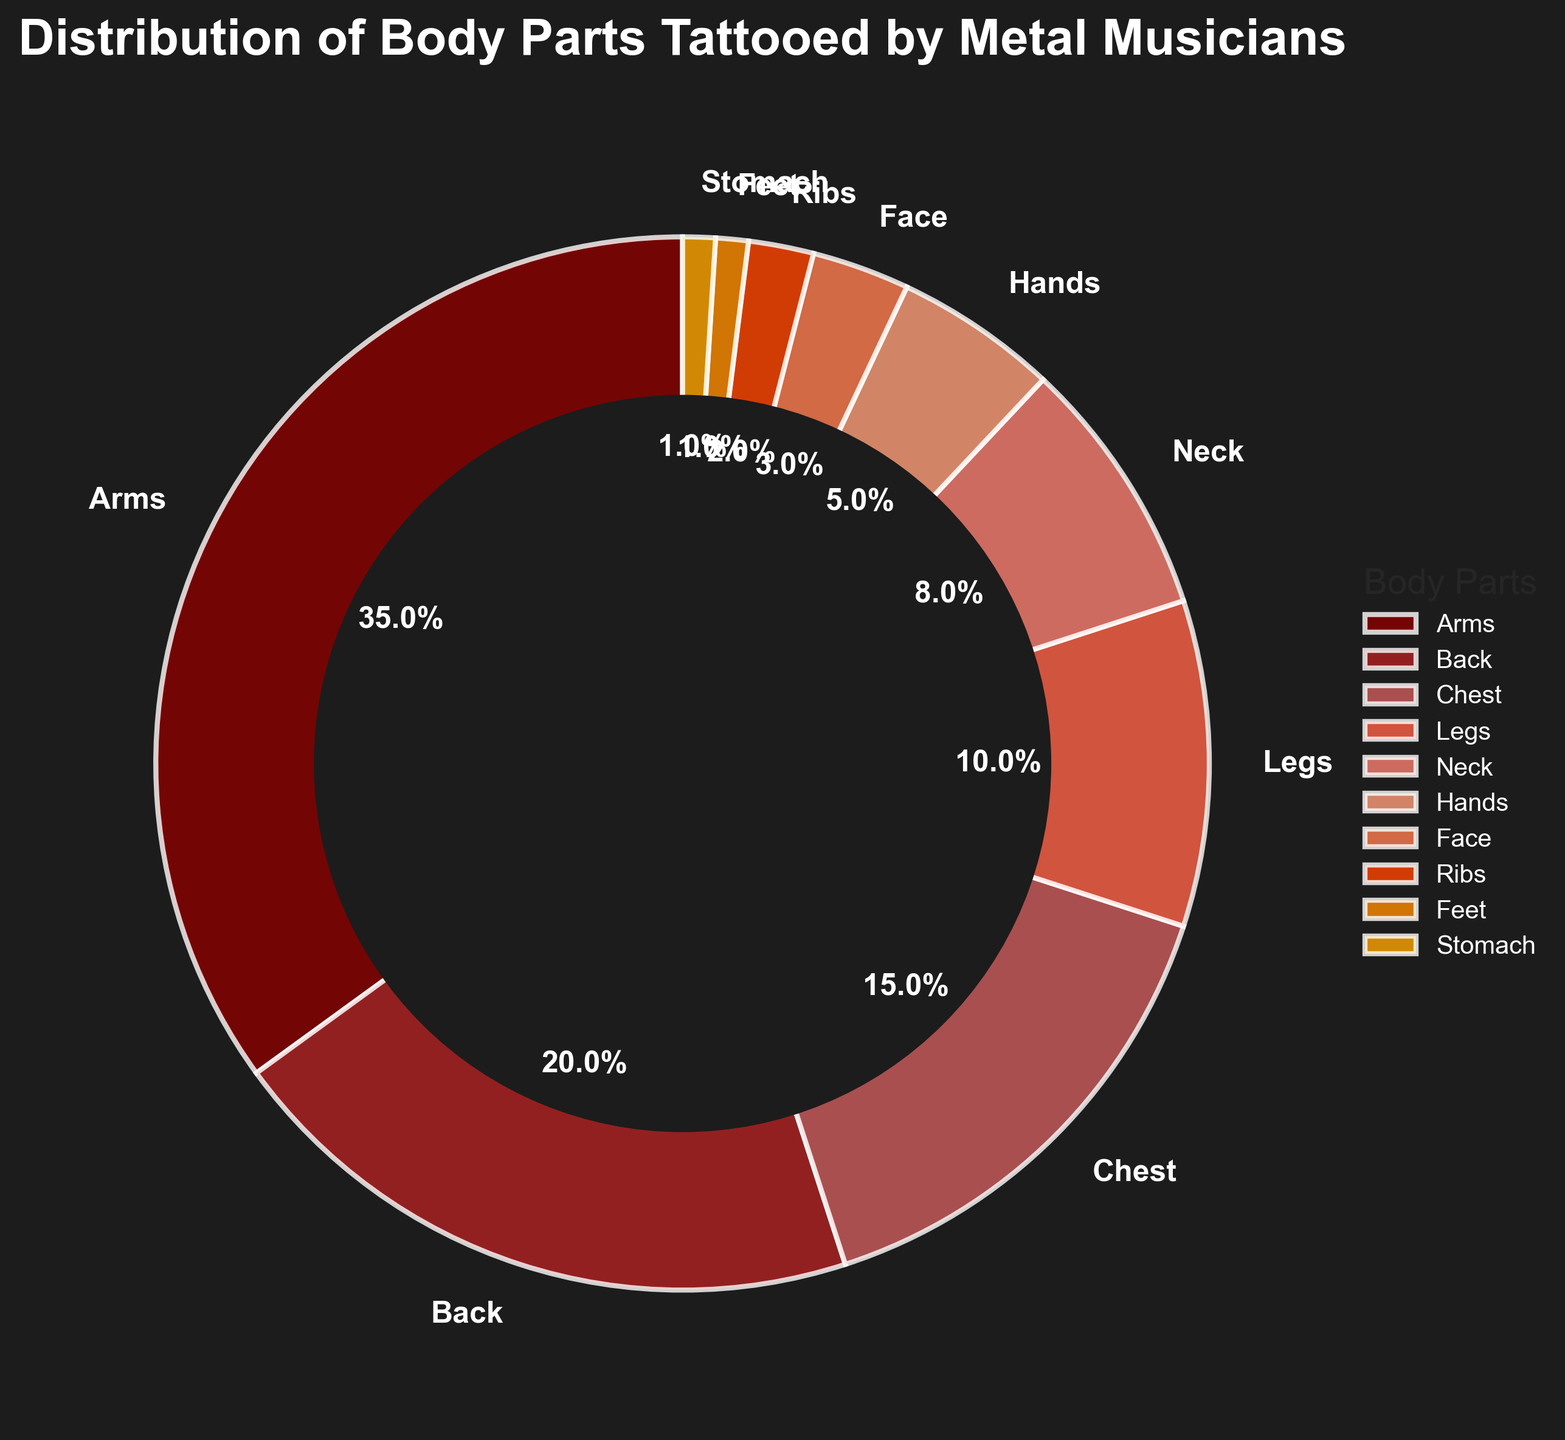Which body part has the highest percentage of tattoos? The body part with the highest percentage is the one with the largest wedge in the pie chart. From the chart, Arms have the largest section.
Answer: Arms What is the total percentage of tattoos on the back and the chest combined? Sum the percentages for Back and Chest from the chart. Back is 20% and Chest is 15%, so the total is 20 + 15.
Answer: 35% Which body part has more tattoos, the neck or the hands? Compare the percentages for Neck and Hands from the chart. Neck has a percentage of 8%, while Hands have a percentage of 5%.
Answer: Neck If you combined the percentages of tattoos on hands, face, ribs, feet, and stomach, would it be more than the percentage of tattoos on legs? Add the percentages for Hands (5%), Face (3%), Ribs (2%), Feet (1%), and Stomach (1%). Their total is 5 + 3 + 2 + 1 + 1 = 12. Compare this to Legs which is 10%.
Answer: Yes Which section of the pie chart is the third largest? Identify the third largest wedge in the pie chart. The largest is Arms, followed by Back. The next largest wedge is Chest.
Answer: Chest Are legs or face more tattooed? Check the percentages for Legs and Face. Legs have a percentage of 10%, and Face has 3%.
Answer: Legs What's the difference in tattoo percentage between legs and neck? Subtract the percentage of Neck (8%) from Legs (10%). The difference is 10 - 8.
Answer: 2% Which two body parts have the smallest percentages of tattoos? Identify the two smallest wedges in the pie chart. The smallest sections are Stomach and Feet, both with 1%.
Answer: Stomach and Feet How does the percentage of tattoos on the chest compare to that on the back? Compare the percentages for Chest and Back. Chest is 15% and Back is 20%. Chest is less than Back.
Answer: Less What is the combined percentage of tattoos on arms, back, and chest? Add the percentages for Arms (35%), Back (20%), and Chest (15%). The total is 35 + 20 + 15.
Answer: 70% 